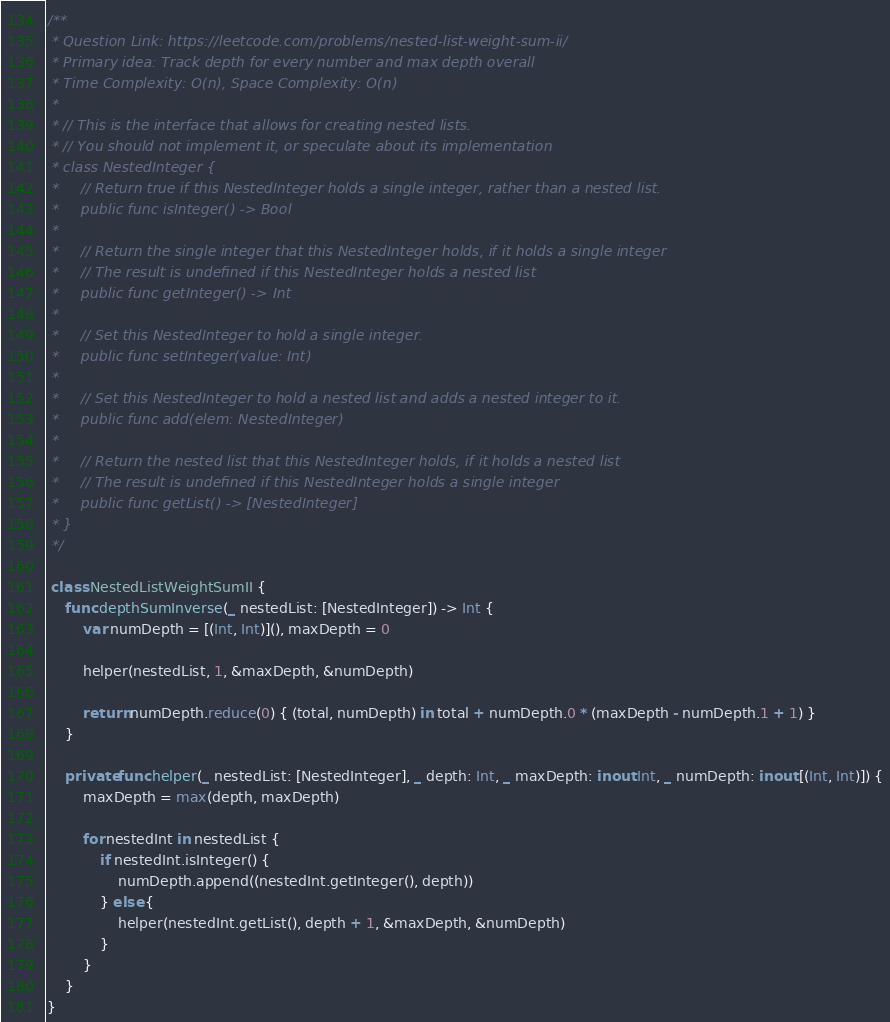Convert code to text. <code><loc_0><loc_0><loc_500><loc_500><_Swift_>/**
 * Question Link: https://leetcode.com/problems/nested-list-weight-sum-ii/
 * Primary idea: Track depth for every number and max depth overall
 * Time Complexity: O(n), Space Complexity: O(n)
 *
 * // This is the interface that allows for creating nested lists.
 * // You should not implement it, or speculate about its implementation
 * class NestedInteger {
 *     // Return true if this NestedInteger holds a single integer, rather than a nested list.
 *     public func isInteger() -> Bool
 *
 *     // Return the single integer that this NestedInteger holds, if it holds a single integer
 *     // The result is undefined if this NestedInteger holds a nested list
 *     public func getInteger() -> Int
 *
 *     // Set this NestedInteger to hold a single integer.
 *     public func setInteger(value: Int)
 *
 *     // Set this NestedInteger to hold a nested list and adds a nested integer to it.
 *     public func add(elem: NestedInteger)
 *
 *     // Return the nested list that this NestedInteger holds, if it holds a nested list
 *     // The result is undefined if this NestedInteger holds a single integer
 *     public func getList() -> [NestedInteger]
 * }
 */

 class NestedListWeightSumII {
    func depthSumInverse(_ nestedList: [NestedInteger]) -> Int {
        var numDepth = [(Int, Int)](), maxDepth = 0
        
        helper(nestedList, 1, &maxDepth, &numDepth)
        
        return numDepth.reduce(0) { (total, numDepth) in total + numDepth.0 * (maxDepth - numDepth.1 + 1) }
    }
    
    private func helper(_ nestedList: [NestedInteger], _ depth: Int, _ maxDepth: inout Int, _ numDepth: inout [(Int, Int)]) {
        maxDepth = max(depth, maxDepth)
        
        for nestedInt in nestedList {
            if nestedInt.isInteger() {
                numDepth.append((nestedInt.getInteger(), depth))
            } else {
                helper(nestedInt.getList(), depth + 1, &maxDepth, &numDepth)
            }
        }
    }
}

</code> 